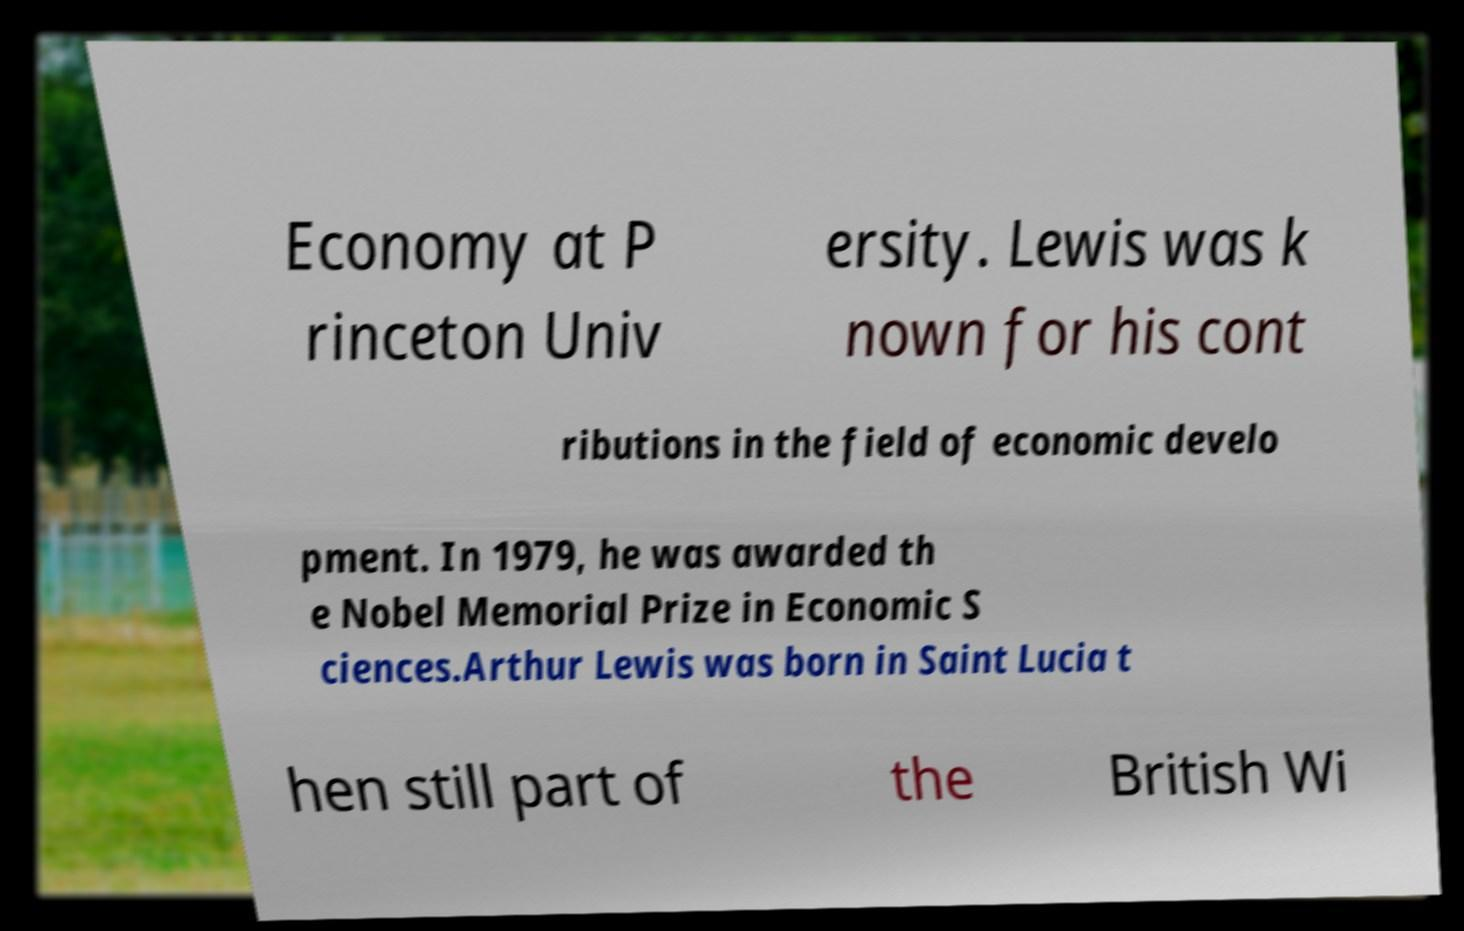Can you accurately transcribe the text from the provided image for me? Economy at P rinceton Univ ersity. Lewis was k nown for his cont ributions in the field of economic develo pment. In 1979, he was awarded th e Nobel Memorial Prize in Economic S ciences.Arthur Lewis was born in Saint Lucia t hen still part of the British Wi 